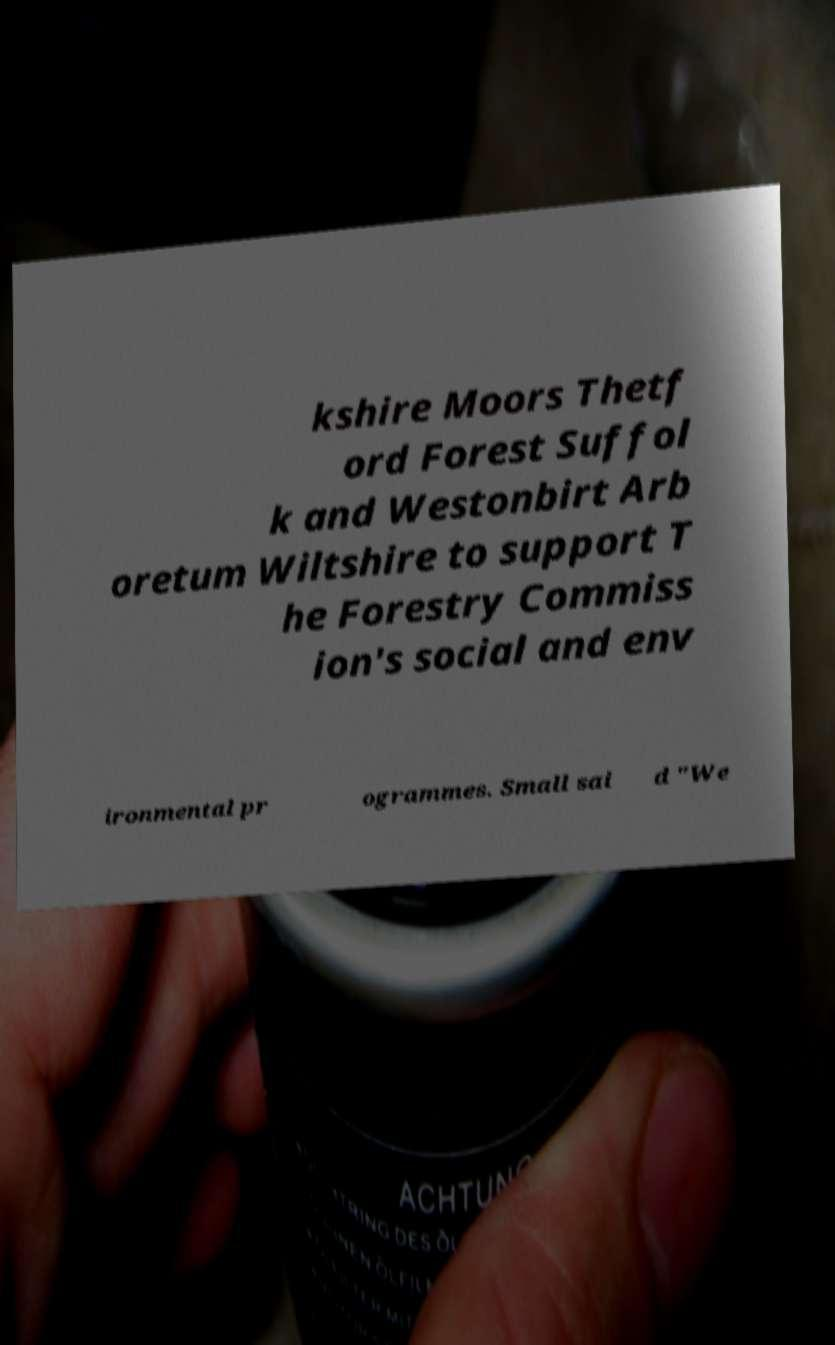Can you accurately transcribe the text from the provided image for me? kshire Moors Thetf ord Forest Suffol k and Westonbirt Arb oretum Wiltshire to support T he Forestry Commiss ion's social and env ironmental pr ogrammes. Small sai d "We 